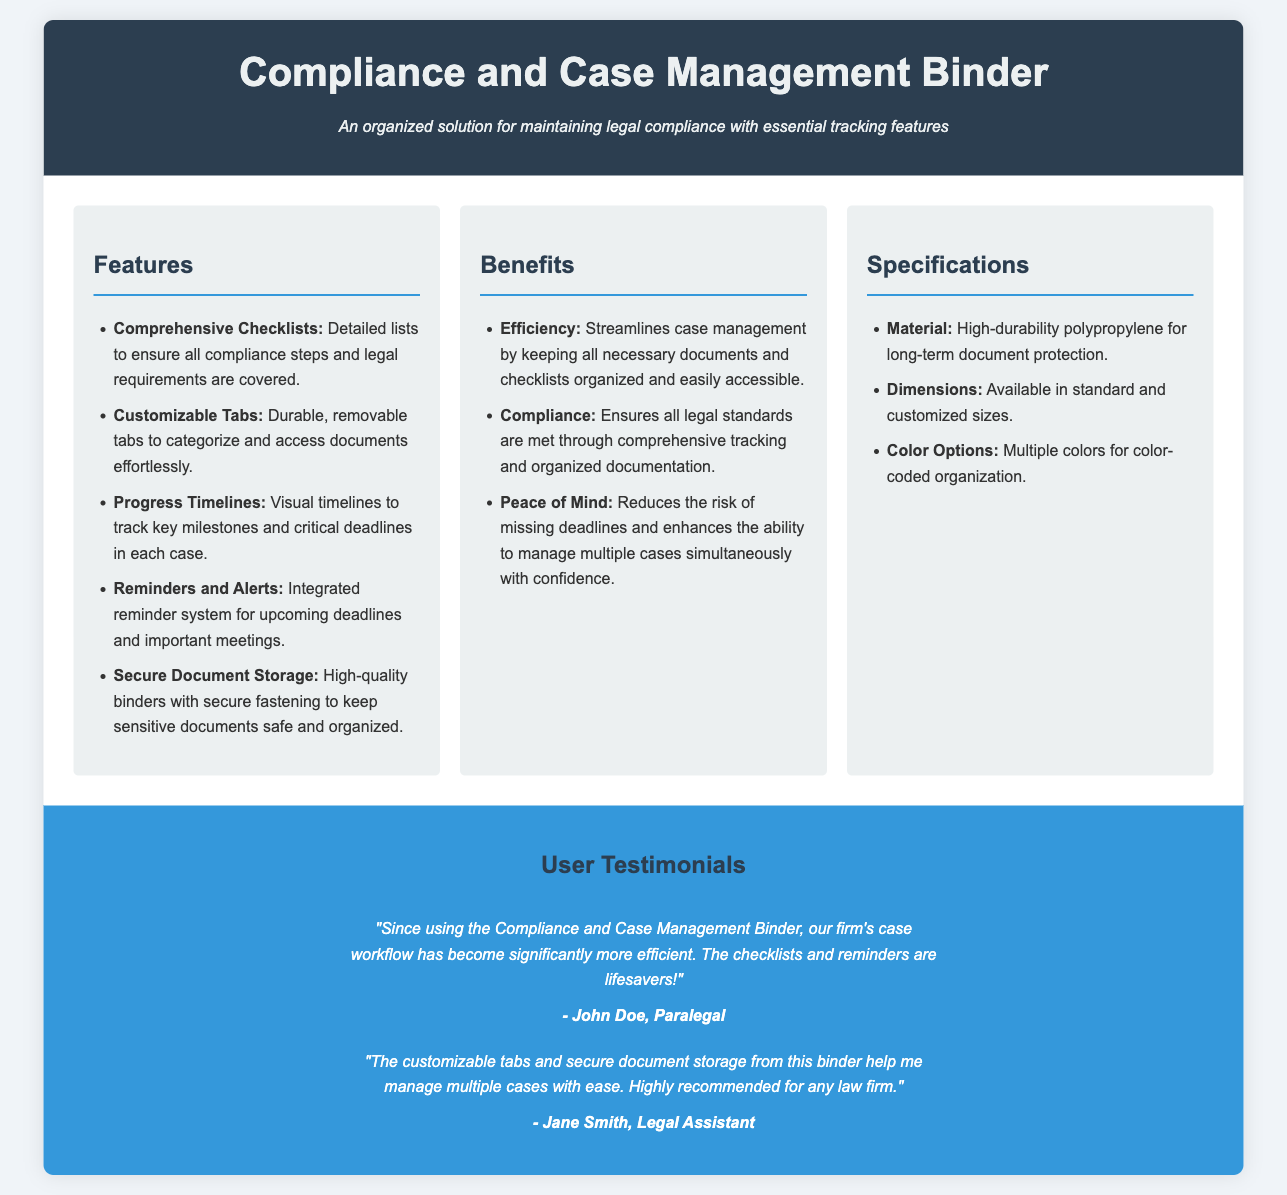What are the key features of the binder? The features section lists five specific features that define the binder, including checklists, tabs, and timelines.
Answer: Comprehensive Checklists, Customizable Tabs, Progress Timelines, Reminders and Alerts, Secure Document Storage How does the binder enhance efficiency? The benefits section explains how the binder improves case management processes and accessibility of documents.
Answer: Streamlines case management What material is the binder made of? The specifications section specifies the high-durability material used for the binder.
Answer: High-durability polypropylene What is one notable benefit mentioned? The benefits section provides three benefits, and one of them is highlighted as enhancing the management of cases.
Answer: Peace of Mind Who provided a testimonial about the binder? The testimonials section includes names of users who shared their experiences with the binder.
Answer: John Doe, Paralegal How many specifications categories are listed? The specifications section is divided into three categories: material, dimensions, and color options.
Answer: Three What type of alerts does the binder provide? The features section notes a specific feature of the binder regarding how it keeps users informed.
Answer: Reminders and Alerts What aspect of case management does the binder help manage? The document emphasizes the binder's utility in a specific area of legal work.
Answer: Multiple cases 